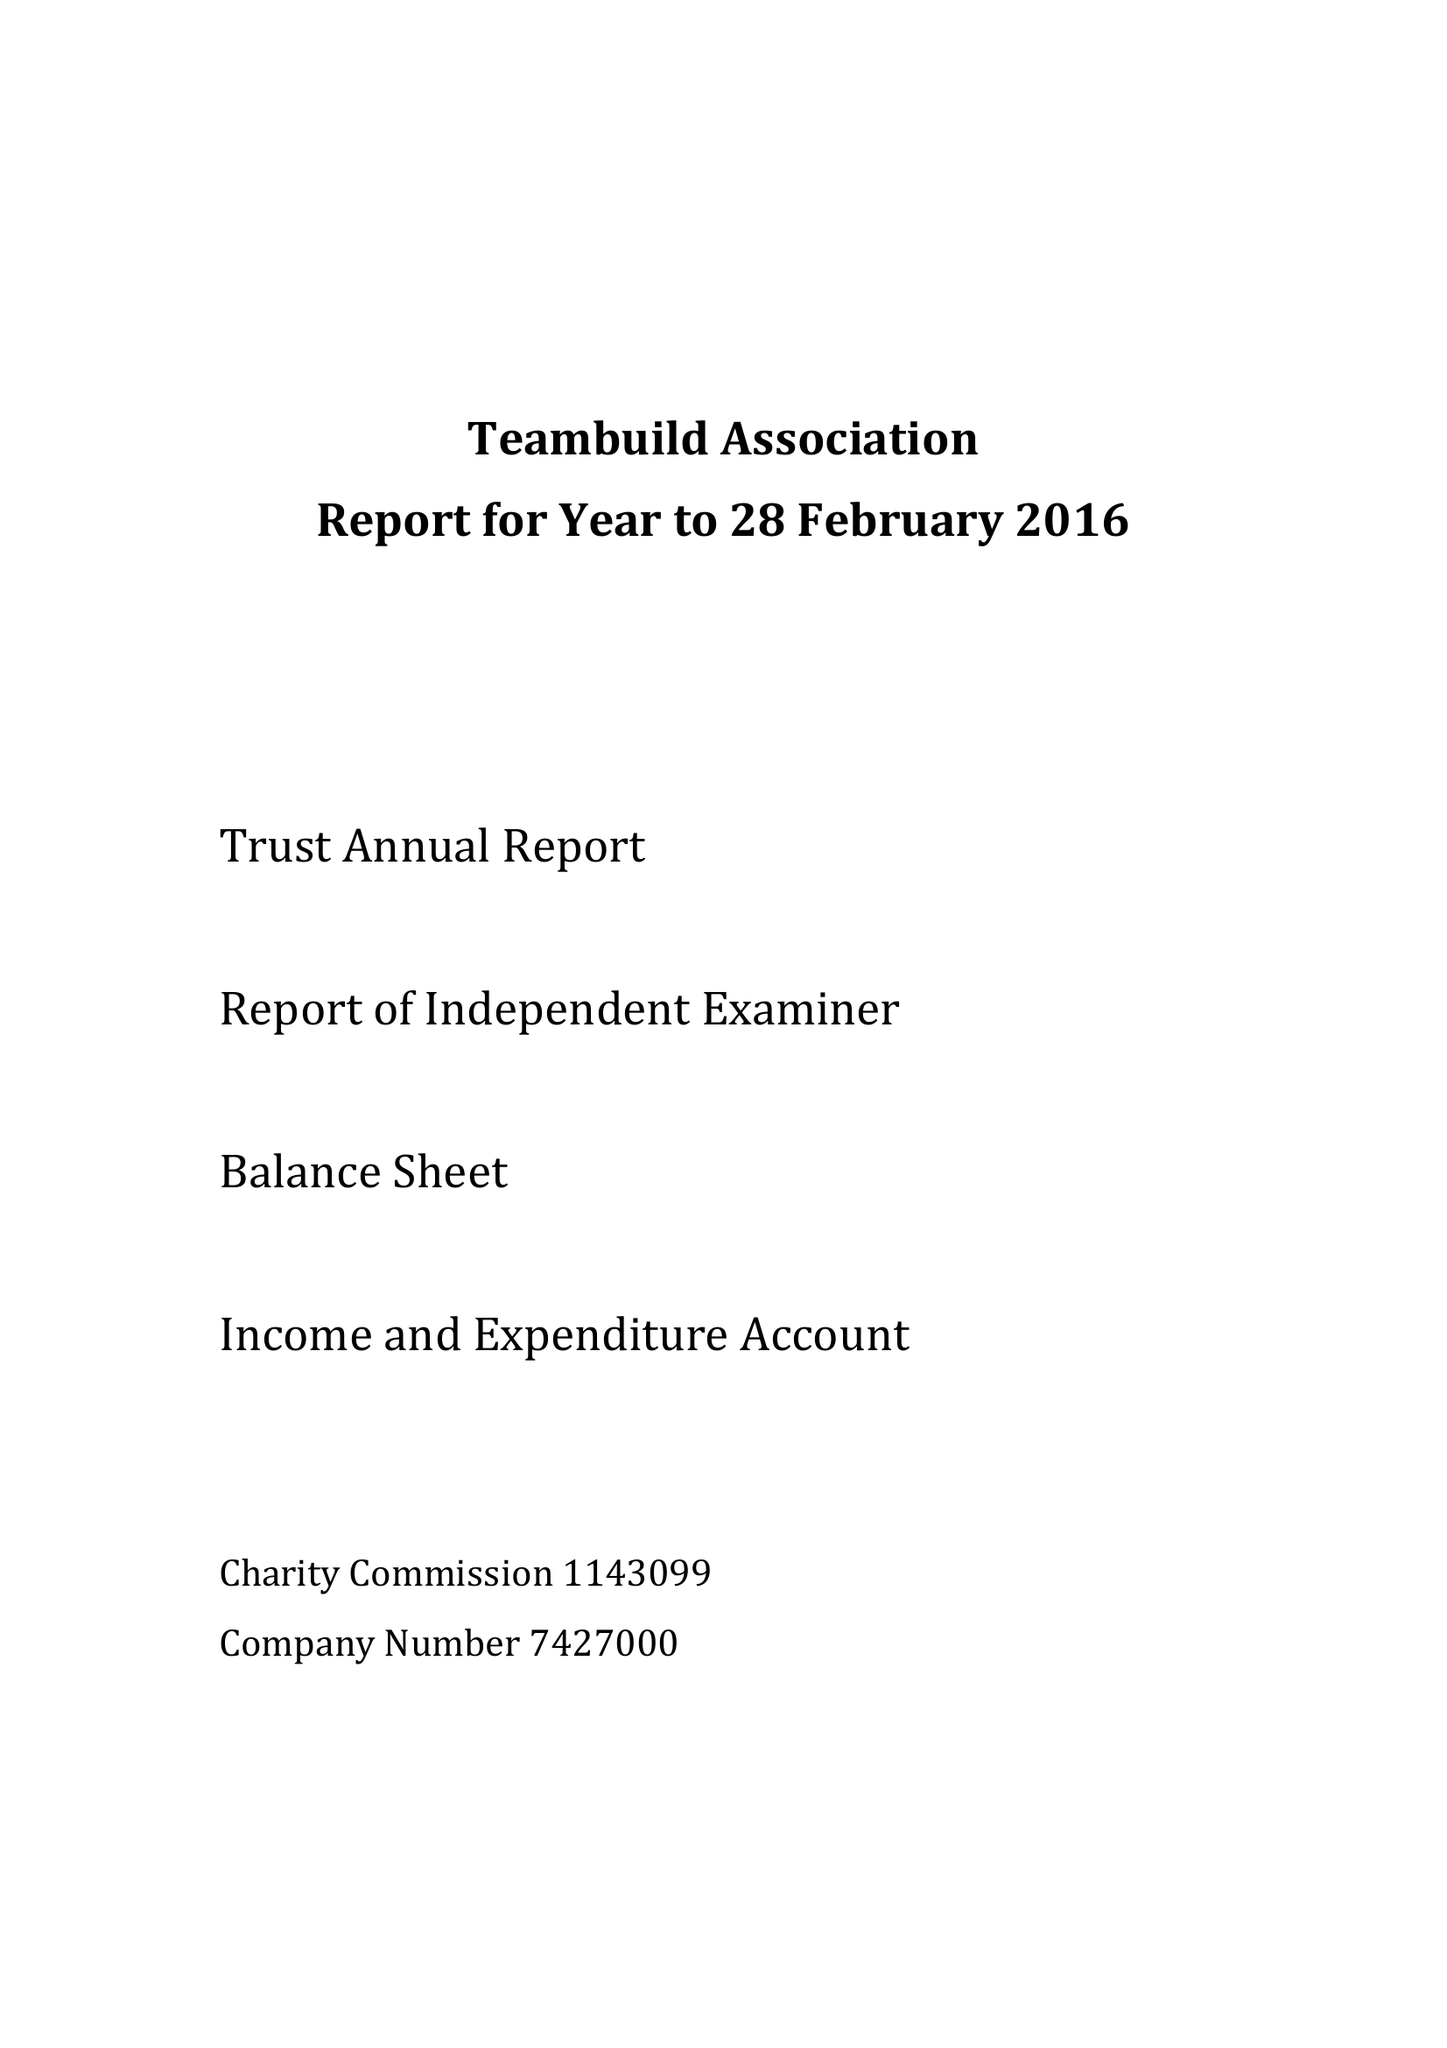What is the value for the charity_name?
Answer the question using a single word or phrase. Teambuild Association 